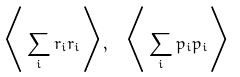<formula> <loc_0><loc_0><loc_500><loc_500>\Big < \sum _ { i } { r } _ { i } { r } _ { i } \Big > , \ \Big < \sum _ { i } { p } _ { i } { p } _ { i } \Big ></formula> 